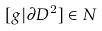<formula> <loc_0><loc_0><loc_500><loc_500>[ g | \partial D ^ { 2 } ] \in N</formula> 